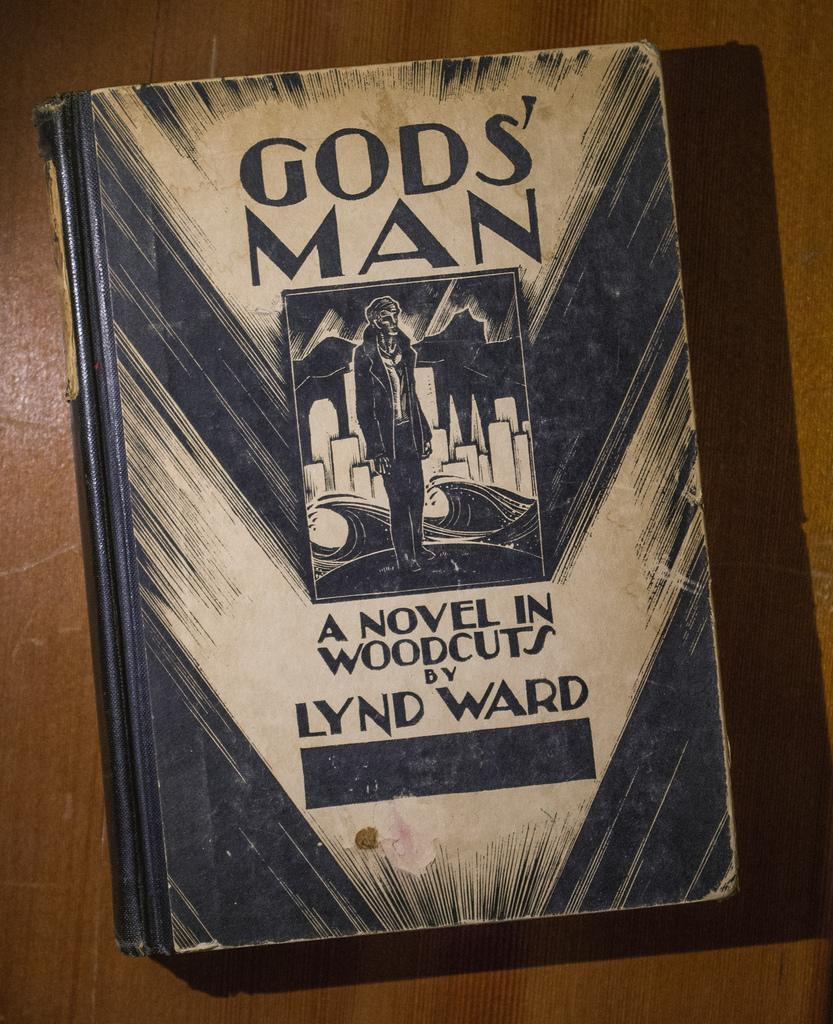<image>
Give a short and clear explanation of the subsequent image. A wood book entitled A novel in woodcuts 